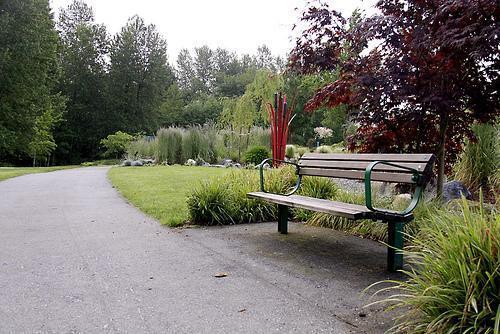How many benches are there?
Give a very brief answer. 1. How many poles support the bench?
Give a very brief answer. 2. How many trees have red leaves?
Give a very brief answer. 1. How many benches are in the tree?
Give a very brief answer. 0. 